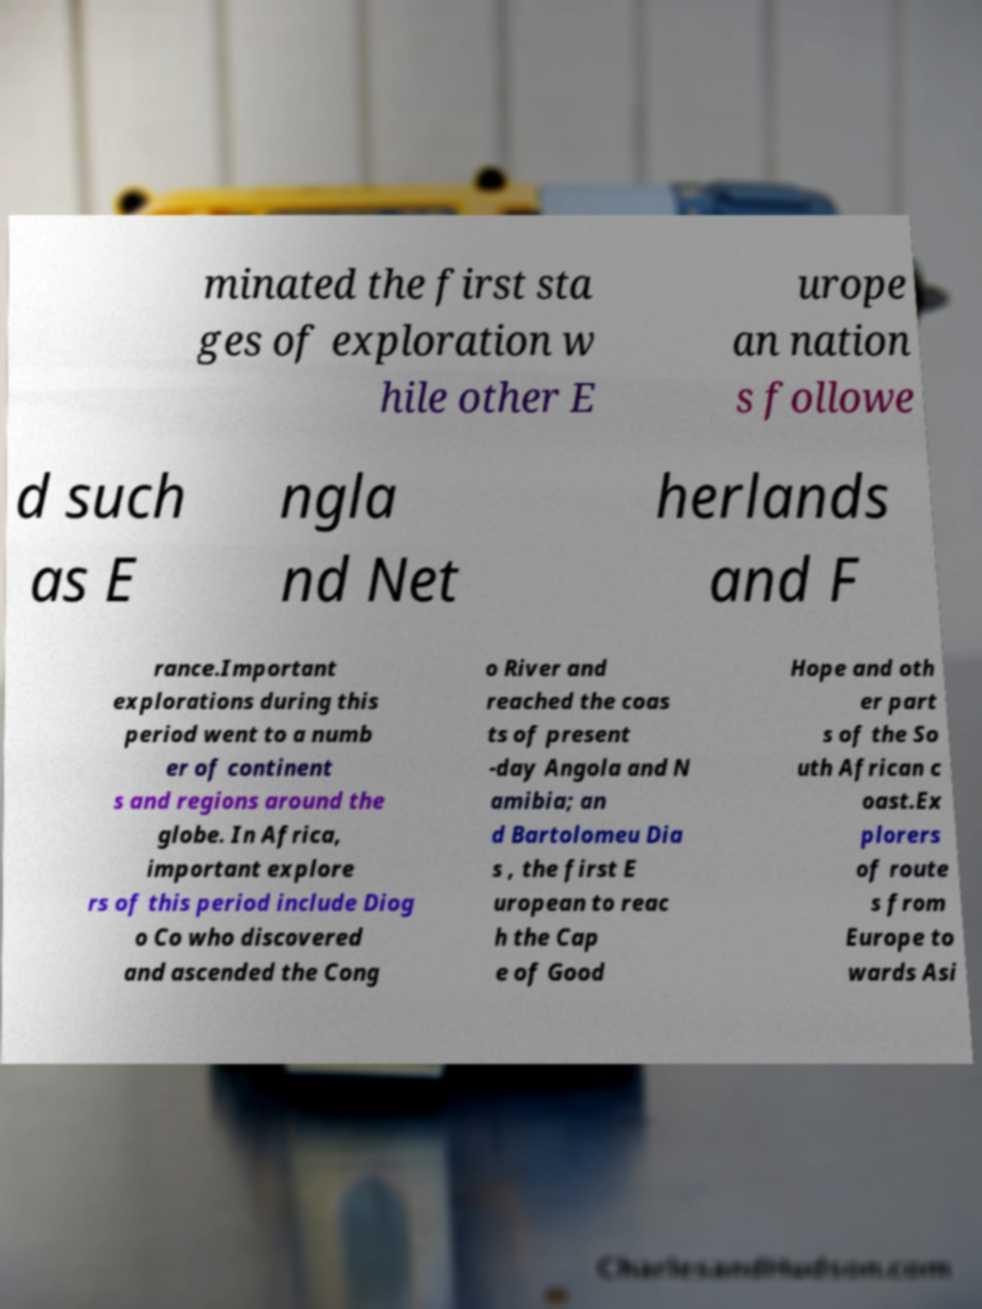Please read and relay the text visible in this image. What does it say? minated the first sta ges of exploration w hile other E urope an nation s followe d such as E ngla nd Net herlands and F rance.Important explorations during this period went to a numb er of continent s and regions around the globe. In Africa, important explore rs of this period include Diog o Co who discovered and ascended the Cong o River and reached the coas ts of present -day Angola and N amibia; an d Bartolomeu Dia s , the first E uropean to reac h the Cap e of Good Hope and oth er part s of the So uth African c oast.Ex plorers of route s from Europe to wards Asi 